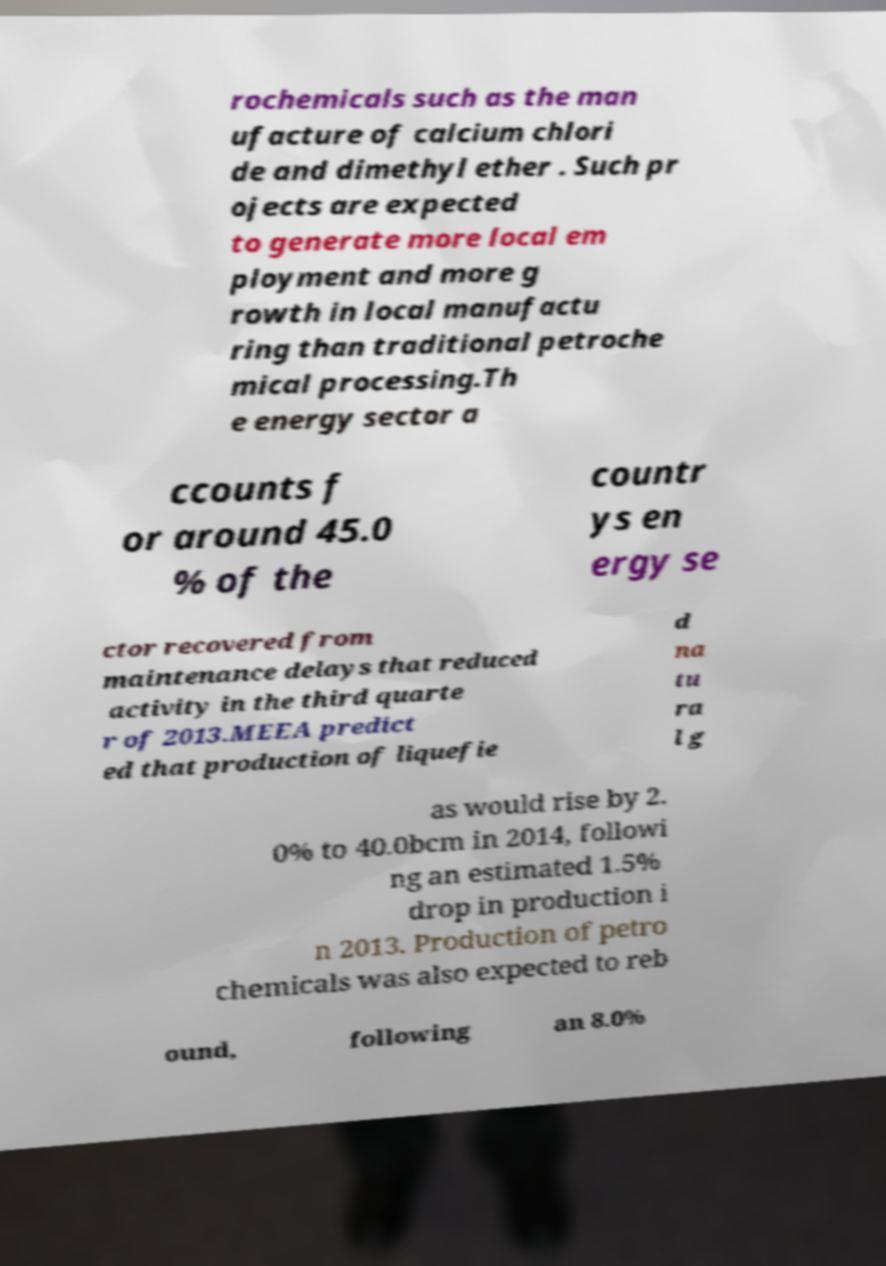What messages or text are displayed in this image? I need them in a readable, typed format. rochemicals such as the man ufacture of calcium chlori de and dimethyl ether . Such pr ojects are expected to generate more local em ployment and more g rowth in local manufactu ring than traditional petroche mical processing.Th e energy sector a ccounts f or around 45.0 % of the countr ys en ergy se ctor recovered from maintenance delays that reduced activity in the third quarte r of 2013.MEEA predict ed that production of liquefie d na tu ra l g as would rise by 2. 0% to 40.0bcm in 2014, followi ng an estimated 1.5% drop in production i n 2013. Production of petro chemicals was also expected to reb ound, following an 8.0% 